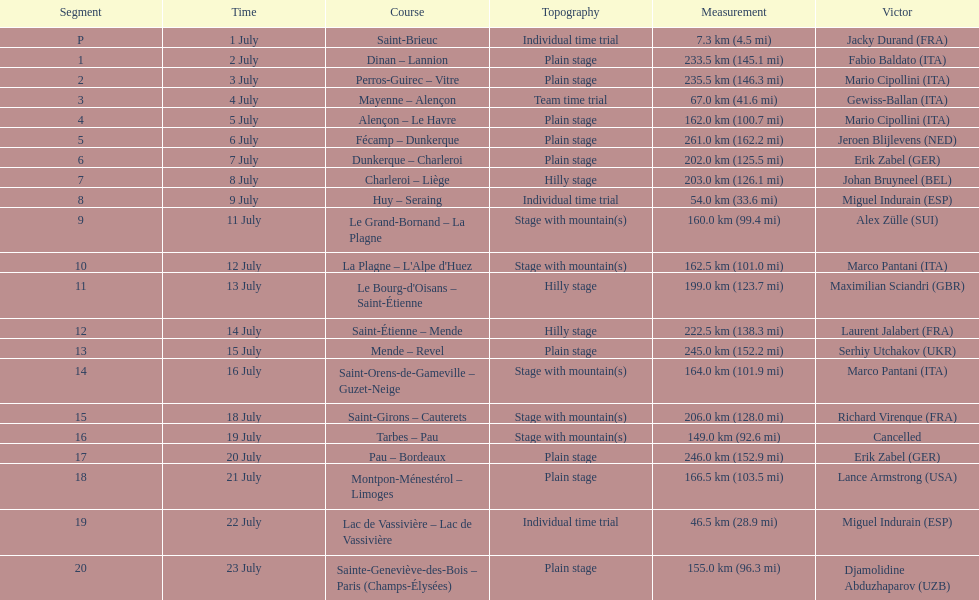How many consecutive km were raced on july 8th? 203.0 km (126.1 mi). 